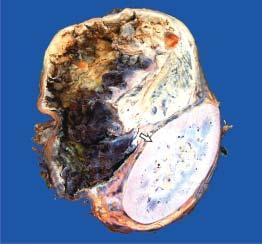does the upper end show a large spherical tumour separate from the kidney?
Answer the question using a single word or phrase. Yes 